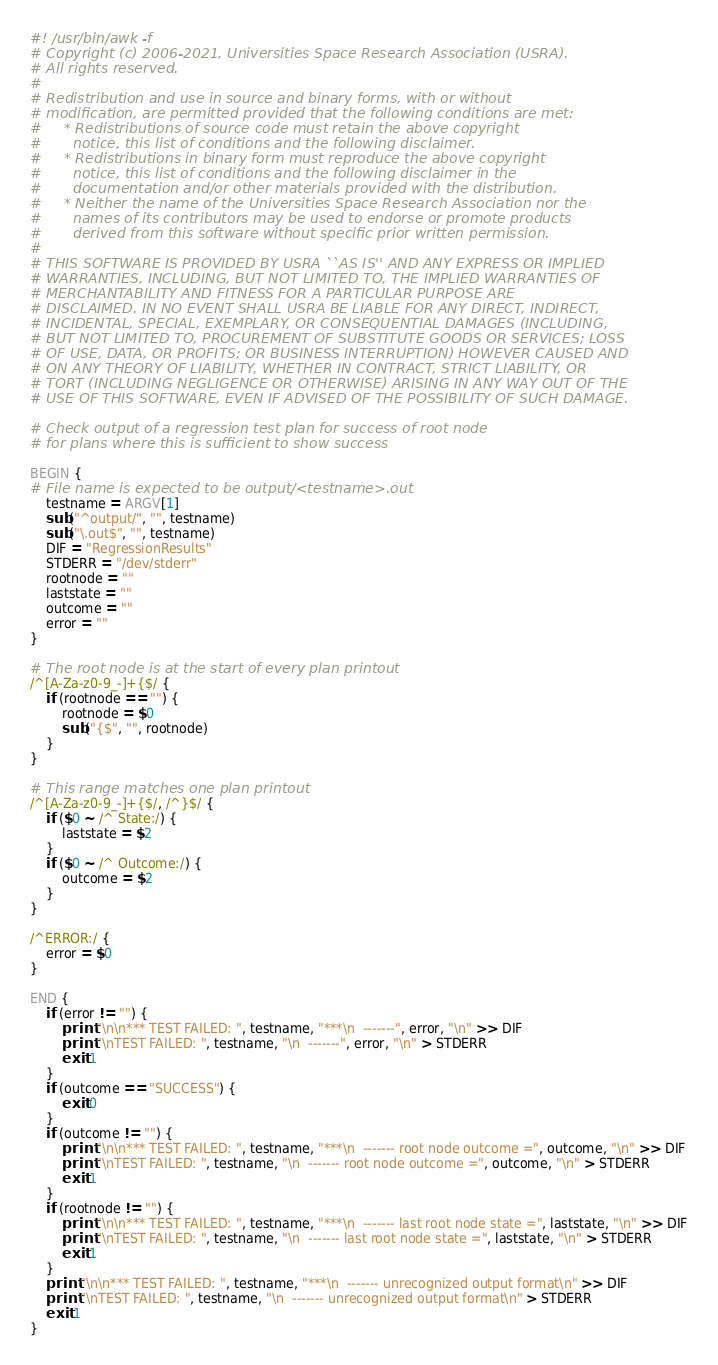Convert code to text. <code><loc_0><loc_0><loc_500><loc_500><_Awk_>#! /usr/bin/awk -f
# Copyright (c) 2006-2021, Universities Space Research Association (USRA).
# All rights reserved.
#
# Redistribution and use in source and binary forms, with or without
# modification, are permitted provided that the following conditions are met:
#     * Redistributions of source code must retain the above copyright
#       notice, this list of conditions and the following disclaimer.
#     * Redistributions in binary form must reproduce the above copyright
#       notice, this list of conditions and the following disclaimer in the
#       documentation and/or other materials provided with the distribution.
#     * Neither the name of the Universities Space Research Association nor the
#       names of its contributors may be used to endorse or promote products
#       derived from this software without specific prior written permission.
#
# THIS SOFTWARE IS PROVIDED BY USRA ``AS IS'' AND ANY EXPRESS OR IMPLIED
# WARRANTIES, INCLUDING, BUT NOT LIMITED TO, THE IMPLIED WARRANTIES OF
# MERCHANTABILITY AND FITNESS FOR A PARTICULAR PURPOSE ARE
# DISCLAIMED. IN NO EVENT SHALL USRA BE LIABLE FOR ANY DIRECT, INDIRECT,
# INCIDENTAL, SPECIAL, EXEMPLARY, OR CONSEQUENTIAL DAMAGES (INCLUDING,
# BUT NOT LIMITED TO, PROCUREMENT OF SUBSTITUTE GOODS OR SERVICES; LOSS
# OF USE, DATA, OR PROFITS; OR BUSINESS INTERRUPTION) HOWEVER CAUSED AND
# ON ANY THEORY OF LIABILITY, WHETHER IN CONTRACT, STRICT LIABILITY, OR
# TORT (INCLUDING NEGLIGENCE OR OTHERWISE) ARISING IN ANY WAY OUT OF THE
# USE OF THIS SOFTWARE, EVEN IF ADVISED OF THE POSSIBILITY OF SUCH DAMAGE.

# Check output of a regression test plan for success of root node
# for plans where this is sufficient to show success

BEGIN {
# File name is expected to be output/<testname>.out
    testname = ARGV[1]
    sub("^output/", "", testname)
    sub("\.out$", "", testname)
    DIF = "RegressionResults"
    STDERR = "/dev/stderr"
    rootnode = ""
    laststate = ""
    outcome = ""
    error = ""
}

# The root node is at the start of every plan printout
/^[A-Za-z0-9_-]+{$/ {
    if (rootnode == "") {
        rootnode = $0
        sub("{$", "", rootnode)
    }
}

# This range matches one plan printout
/^[A-Za-z0-9_-]+{$/, /^}$/ {
    if ($0 ~ /^ State:/) {
        laststate = $2
    }
    if ($0 ~ /^ Outcome:/) {
        outcome = $2
    }
}

/^ERROR:/ {
    error = $0
}

END {
    if (error != "") {
        print "\n\n*** TEST FAILED: ", testname, "***\n  -------", error, "\n" >> DIF
        print "\nTEST FAILED: ", testname, "\n  -------", error, "\n" > STDERR
        exit 1
    }
    if (outcome == "SUCCESS") {
        exit 0
    }
    if (outcome != "") {
        print "\n\n*** TEST FAILED: ", testname, "***\n  ------- root node outcome =", outcome, "\n" >> DIF
        print "\nTEST FAILED: ", testname, "\n  ------- root node outcome =", outcome, "\n" > STDERR
        exit 1
    }
    if (rootnode != "") {
        print "\n\n*** TEST FAILED: ", testname, "***\n  ------- last root node state =", laststate, "\n" >> DIF
        print "\nTEST FAILED: ", testname, "\n  ------- last root node state =", laststate, "\n" > STDERR
        exit 1
    }
    print "\n\n*** TEST FAILED: ", testname, "***\n  ------- unrecognized output format\n" >> DIF
    print "\nTEST FAILED: ", testname, "\n  ------- unrecognized output format\n" > STDERR
    exit 1
}
</code> 